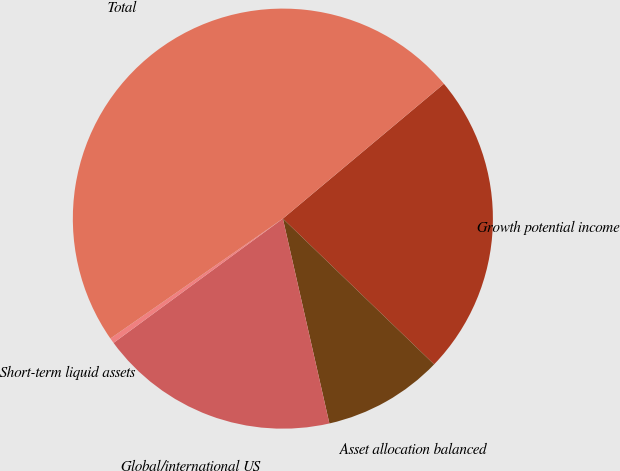<chart> <loc_0><loc_0><loc_500><loc_500><pie_chart><fcel>Growth potential income<fcel>Asset allocation balanced<fcel>Global/international US<fcel>Short-term liquid assets<fcel>Total<nl><fcel>23.3%<fcel>9.24%<fcel>18.48%<fcel>0.41%<fcel>48.57%<nl></chart> 